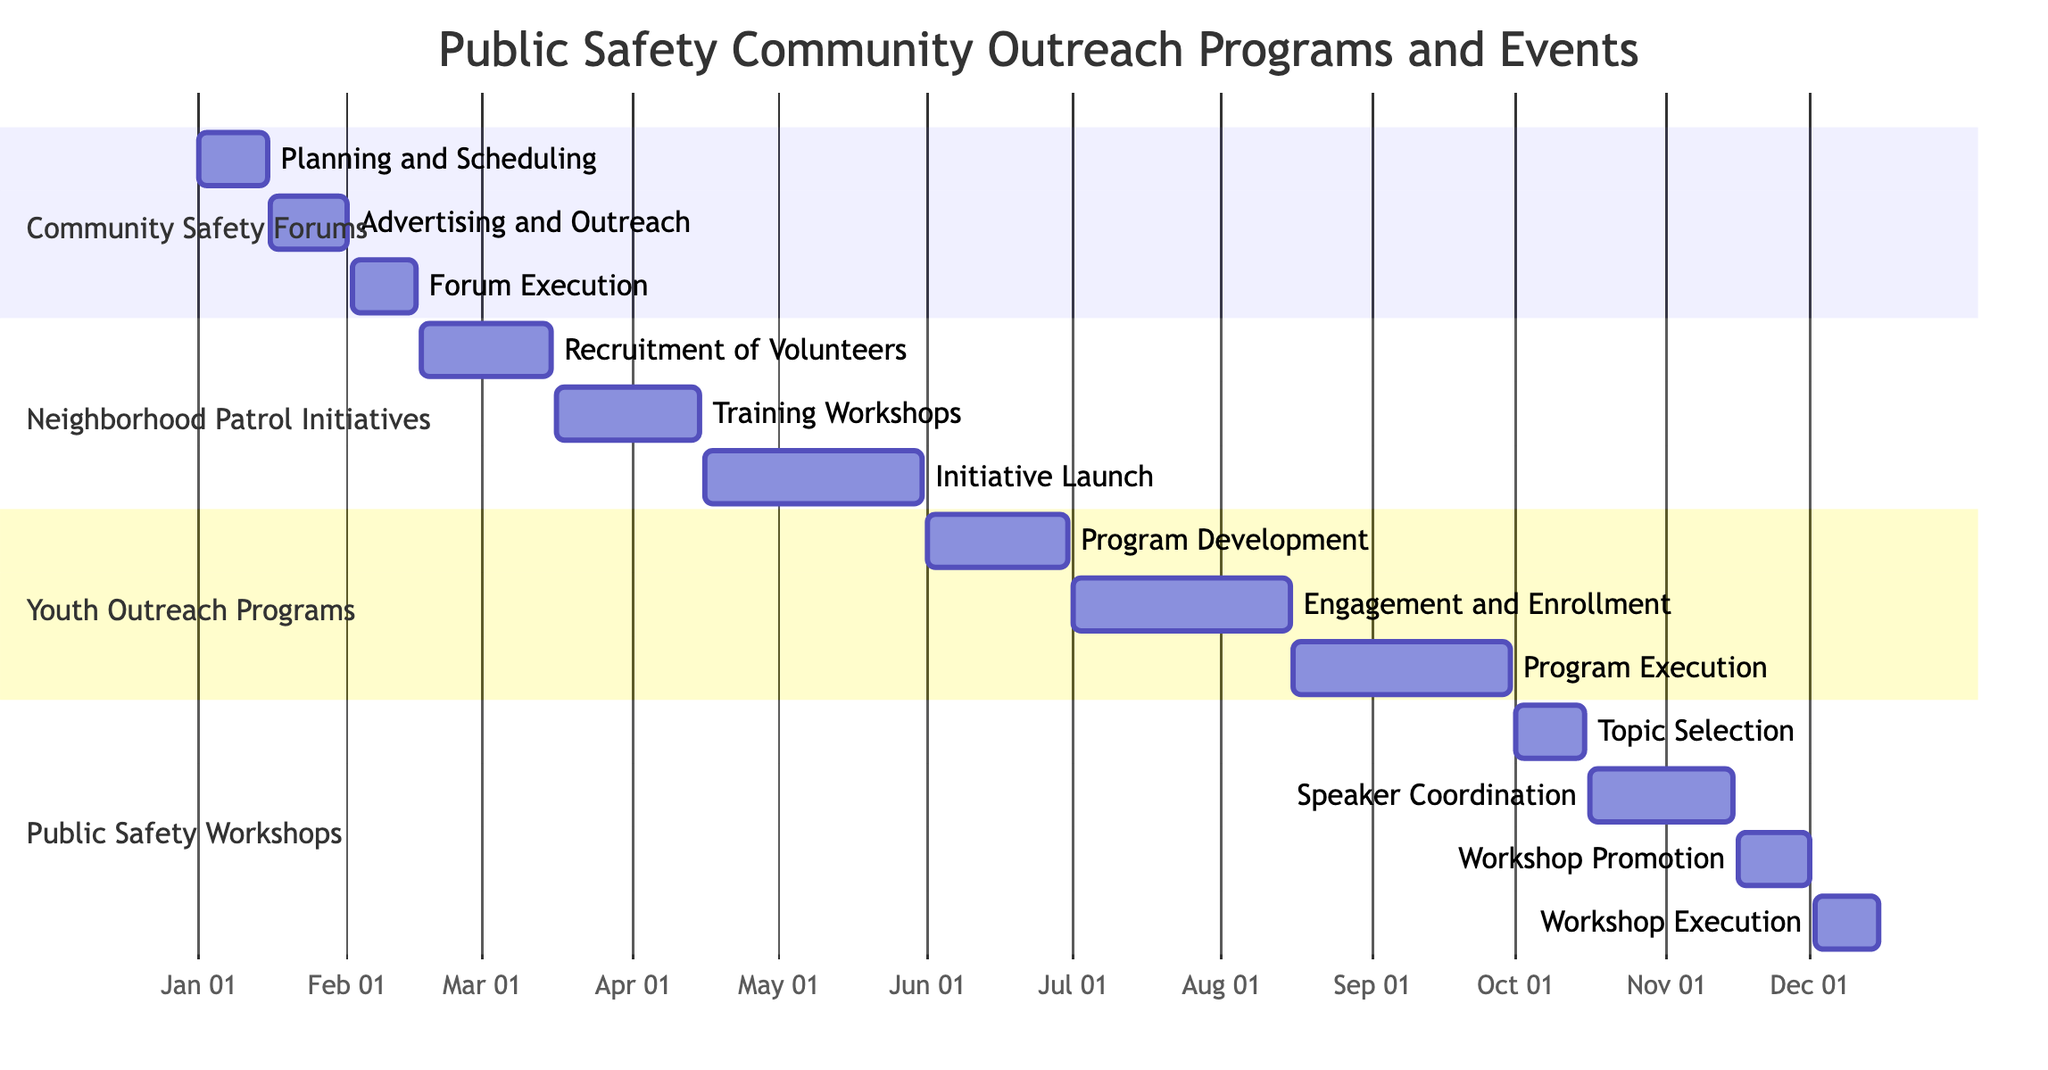What is the duration of the Community Safety Forums? The start date for the Community Safety Forums is January 1, 2023, and the end date is February 15, 2023. The duration can be calculated by counting the days between these two dates, which is 46 days.
Answer: 46 days How many tasks are included in the Youth Outreach Programs? The Youth Outreach Programs have three tasks listed: Program Development, Engagement and Enrollment, and Program Execution. Therefore, the total number of tasks is three.
Answer: 3 When does the Neighborhood Patrol Initiatives phase begin? Looking at the timeline of the Neighborhood Patrol Initiatives, it starts on February 16, 2023, which is clearly marked at the beginning of this section of the Gantt Chart.
Answer: February 16, 2023 What is the finishing date for the Public Safety Workshops? The final task of the Public Safety Workshops is Workshop Execution, which ends on December 15, 2023. This date signifies the completion of the entire phase.
Answer: December 15, 2023 Which task in the Community Safety Forums overlaps with the Advertising and Outreach task? The task Forum Execution starts on February 2, 2023, and overlaps with the Advertising and Outreach task, which ends on February 1, 2023. Therefore, Forum Execution is the task that overlaps with Advertising and Outreach.
Answer: Forum Execution What is the total period covered by all outreach programs in the Gantt chart? To determine the total period, we check the start date of the earliest event which is January 1, 2023, and end date of the latest event which is December 15, 2023. The period between these dates is 348 days.
Answer: 348 days Which task has the latest starting date among all tasks listed in the chart? Upon reviewing the start dates of all tasks, the last one to begin is Workshop Promotion, which starts on November 16, 2023. No other task starts after this date, making it the latest.
Answer: Workshop Promotion What is the total number of sections in the Gantt chart? The Gantt chart contains four distinct sections: Community Safety Forums, Neighborhood Patrol Initiatives, Youth Outreach Programs, and Public Safety Workshops. Thus, the total number of sections is four.
Answer: 4 During which month does the Initiative Launch take place? Looking at the tasks under Neighborhood Patrol Initiatives, the Initiative Launch starts on April 16 and ends on May 31, 2023. Thus, it spans the months of April and May.
Answer: April and May 